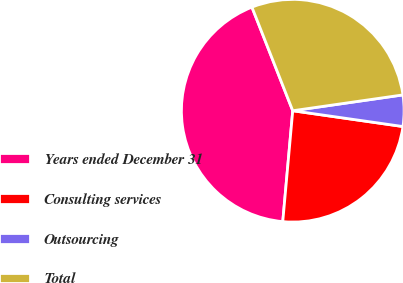Convert chart to OTSL. <chart><loc_0><loc_0><loc_500><loc_500><pie_chart><fcel>Years ended December 31<fcel>Consulting services<fcel>Outsourcing<fcel>Total<nl><fcel>42.6%<fcel>24.16%<fcel>4.54%<fcel>28.7%<nl></chart> 